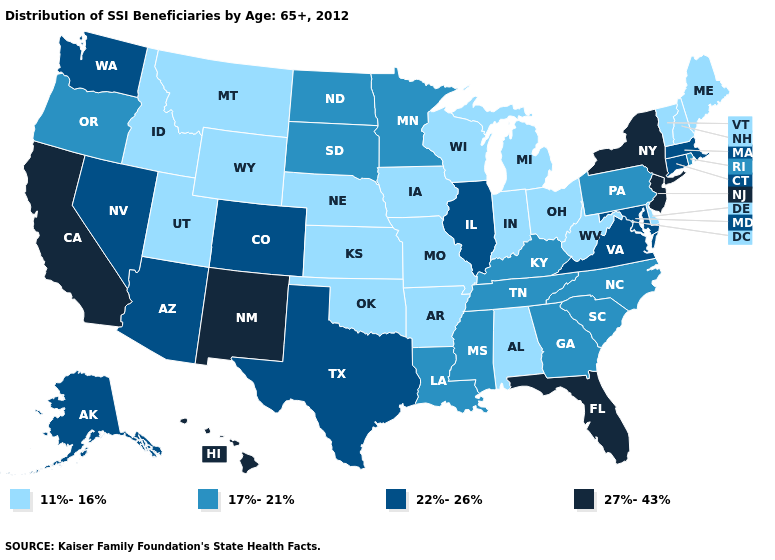What is the value of Oregon?
Keep it brief. 17%-21%. What is the lowest value in states that border Iowa?
Quick response, please. 11%-16%. Does Virginia have a lower value than West Virginia?
Write a very short answer. No. What is the value of North Carolina?
Concise answer only. 17%-21%. Does Iowa have the same value as Vermont?
Answer briefly. Yes. What is the value of North Carolina?
Write a very short answer. 17%-21%. Among the states that border Texas , does Louisiana have the lowest value?
Concise answer only. No. Name the states that have a value in the range 22%-26%?
Be succinct. Alaska, Arizona, Colorado, Connecticut, Illinois, Maryland, Massachusetts, Nevada, Texas, Virginia, Washington. How many symbols are there in the legend?
Concise answer only. 4. Does Florida have the highest value in the South?
Concise answer only. Yes. Among the states that border Washington , which have the lowest value?
Give a very brief answer. Idaho. Name the states that have a value in the range 11%-16%?
Quick response, please. Alabama, Arkansas, Delaware, Idaho, Indiana, Iowa, Kansas, Maine, Michigan, Missouri, Montana, Nebraska, New Hampshire, Ohio, Oklahoma, Utah, Vermont, West Virginia, Wisconsin, Wyoming. What is the highest value in states that border Massachusetts?
Answer briefly. 27%-43%. Among the states that border Kansas , which have the lowest value?
Write a very short answer. Missouri, Nebraska, Oklahoma. Does Kansas have the highest value in the USA?
Be succinct. No. 